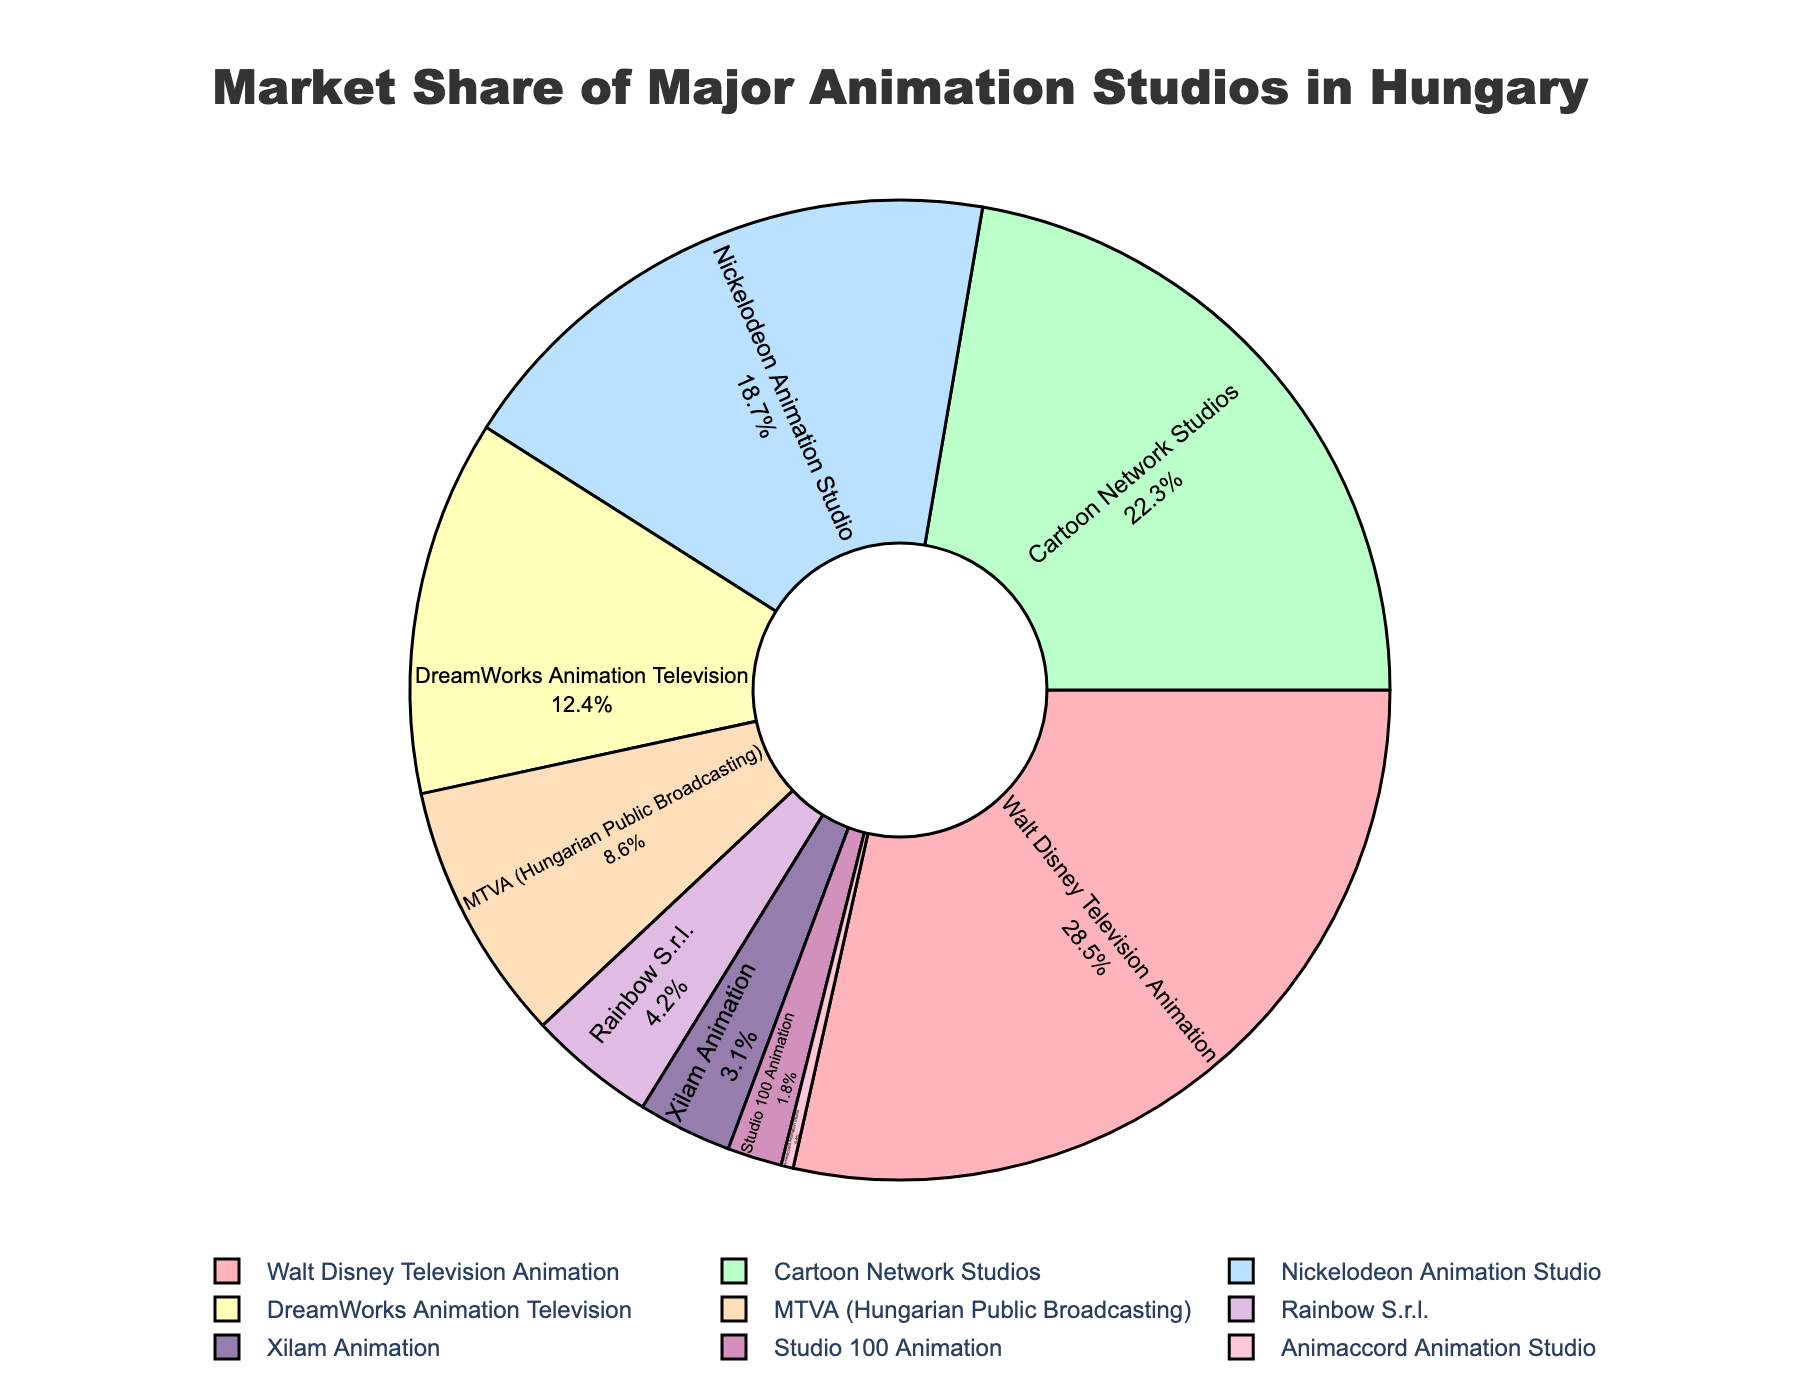Which studio has the highest market share? The figure shows the market share of each studio. Walt Disney Television Animation has the largest slice.
Answer: Walt Disney Television Animation Which two studios have the closest market share? By looking at the sizes of the slices, MTVA and Rainbow S.r.l. seem to be the closest. MTVA has 8.6% and Rainbow S.r.l. has 4.2%, so their difference is 4.4%, which is the smallest gap.
Answer: MTVA and Rainbow S.r.l What is the combined market share of Walt Disney Television Animation and Cartoon Network Studios? Walt Disney Television Animation has a 28.5% share and Cartoon Network Studios has a 22.3% share. Add these two percentages: 28.5% + 22.3% = 50.8%.
Answer: 50.8% What is the difference in market share between DreamWorks Animation Television and MTVA? DreamWorks Animation Television has a 12.4% share and MTVA has 8.6%. Subtract these percentages: 12.4% - 8.6% = 3.8%.
Answer: 3.8% How many studios have a market share less than 5%? By checking the slices, we identify Rainbow S.r.l., Xilam Animation, Studio 100 Animation, and Animaccord Animation Studio, making a total of 4 studios.
Answer: 4 What is the market share of the studio with the smallest percentage? Animaccord Animation Studio has the smallest slice with a 0.4% share.
Answer: 0.4% Which studio has a greater market share: Rainbow S.r.l. or Studio 100 Animation? Rainbow S.r.l. has a market share of 4.2%, whereas Studio 100 Animation has 1.8%. Therefore, Rainbow S.r.l. has a greater market share.
Answer: Rainbow S.r.l What is the average market share of the studios with less than 10%? The studios with less than 10% are MTVA (8.6%), Rainbow S.r.l. (4.2%), Xilam Animation (3.1%), Studio 100 Animation (1.8%), and Animaccord Animation Studio (0.4%). Sum these and divide by 5: (8.6 + 4.2 + 3.1 + 1.8 + 0.4) / 5 = 3.62%.
Answer: 3.62% Which studio has a larger market share: Nickelodeon Animation Studio or DreamWorks Animation Television? Nickelodeon Animation Studio has an 18.7% share, whereas DreamWorks Animation Television has 12.4%. Therefore, Nickelodeon Animation Studio has a larger share.
Answer: Nickelodeon Animation Studio 